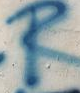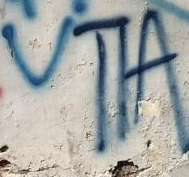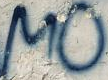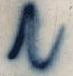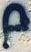Read the text from these images in sequence, separated by a semicolon. R; VTIA; MO; N; p 